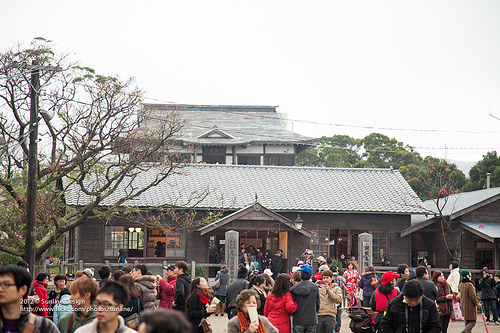<image>
Is the tree behind the house? No. The tree is not behind the house. From this viewpoint, the tree appears to be positioned elsewhere in the scene. 